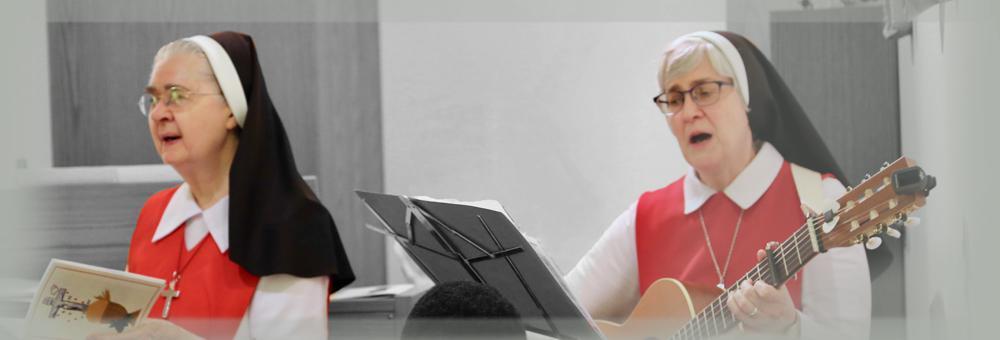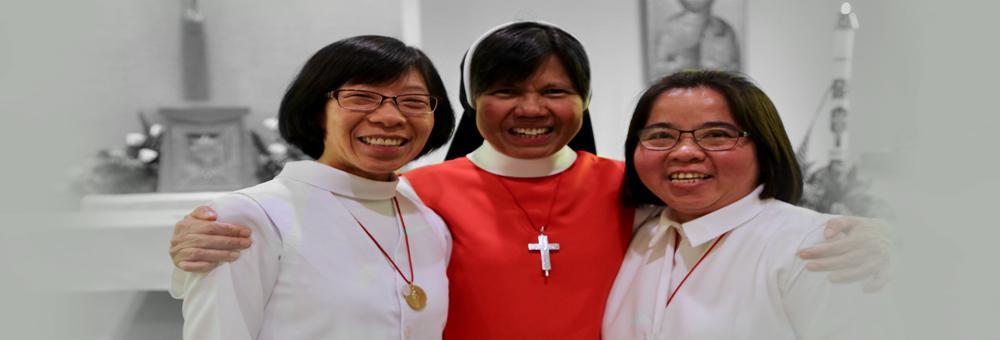The first image is the image on the left, the second image is the image on the right. Analyze the images presented: Is the assertion "There are women and no men." valid? Answer yes or no. Yes. The first image is the image on the left, the second image is the image on the right. Considering the images on both sides, is "Each image includes a woman wearing red and white and a woman wearing a black-and-white head covering, and the left image contains two people, while the right image contains three people." valid? Answer yes or no. Yes. 